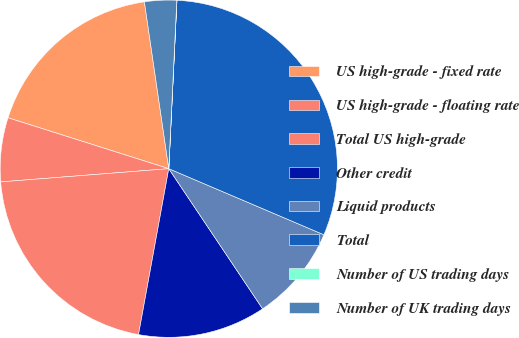Convert chart to OTSL. <chart><loc_0><loc_0><loc_500><loc_500><pie_chart><fcel>US high-grade - fixed rate<fcel>US high-grade - floating rate<fcel>Total US high-grade<fcel>Other credit<fcel>Liquid products<fcel>Total<fcel>Number of US trading days<fcel>Number of UK trading days<nl><fcel>17.81%<fcel>6.13%<fcel>20.88%<fcel>12.26%<fcel>9.2%<fcel>30.64%<fcel>0.01%<fcel>3.07%<nl></chart> 